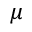<formula> <loc_0><loc_0><loc_500><loc_500>\mu</formula> 